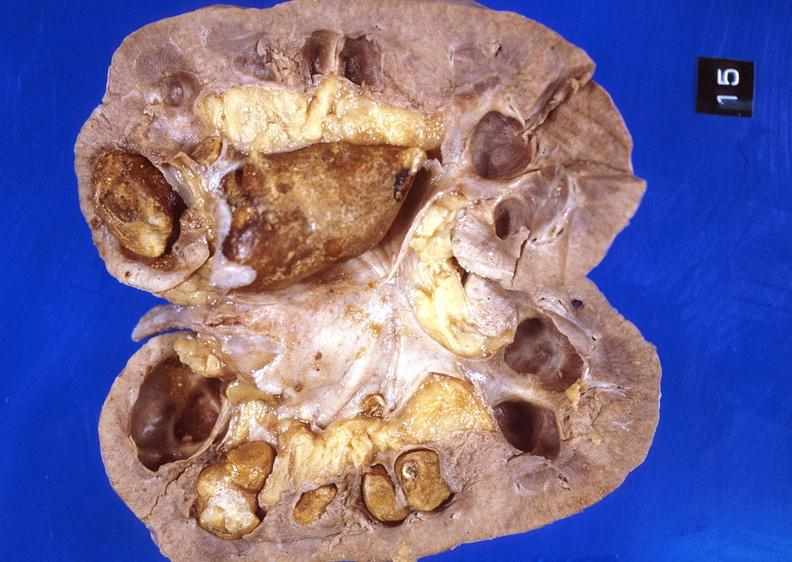does photo show kidney, staghorn calculi?
Answer the question using a single word or phrase. No 